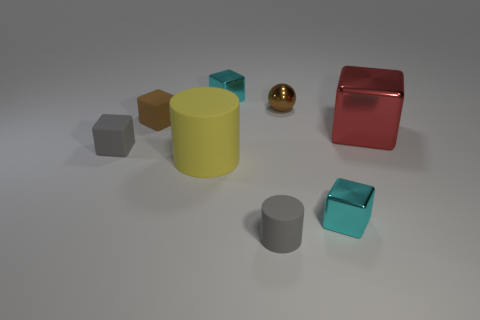Is the color of the object behind the brown metal thing the same as the small metal block that is in front of the tiny brown cube?
Ensure brevity in your answer.  Yes. There is a tiny gray object to the left of the small brown matte thing; what material is it?
Your answer should be very brief. Rubber. What color is the big block that is the same material as the small sphere?
Give a very brief answer. Red. What number of cyan cubes have the same size as the gray rubber block?
Provide a short and direct response. 2. There is a block behind the shiny ball; does it have the same size as the small brown matte block?
Give a very brief answer. Yes. What shape is the tiny matte thing that is on the right side of the tiny gray rubber block and in front of the big red thing?
Your answer should be compact. Cylinder. Are there any big yellow rubber things to the left of the metal ball?
Provide a short and direct response. Yes. Is there anything else that has the same shape as the small brown metallic object?
Your answer should be compact. No. Do the red object and the small brown rubber object have the same shape?
Your response must be concise. Yes. Are there an equal number of blocks that are to the left of the small brown matte cube and small cyan blocks to the left of the large red metal cube?
Provide a short and direct response. No. 